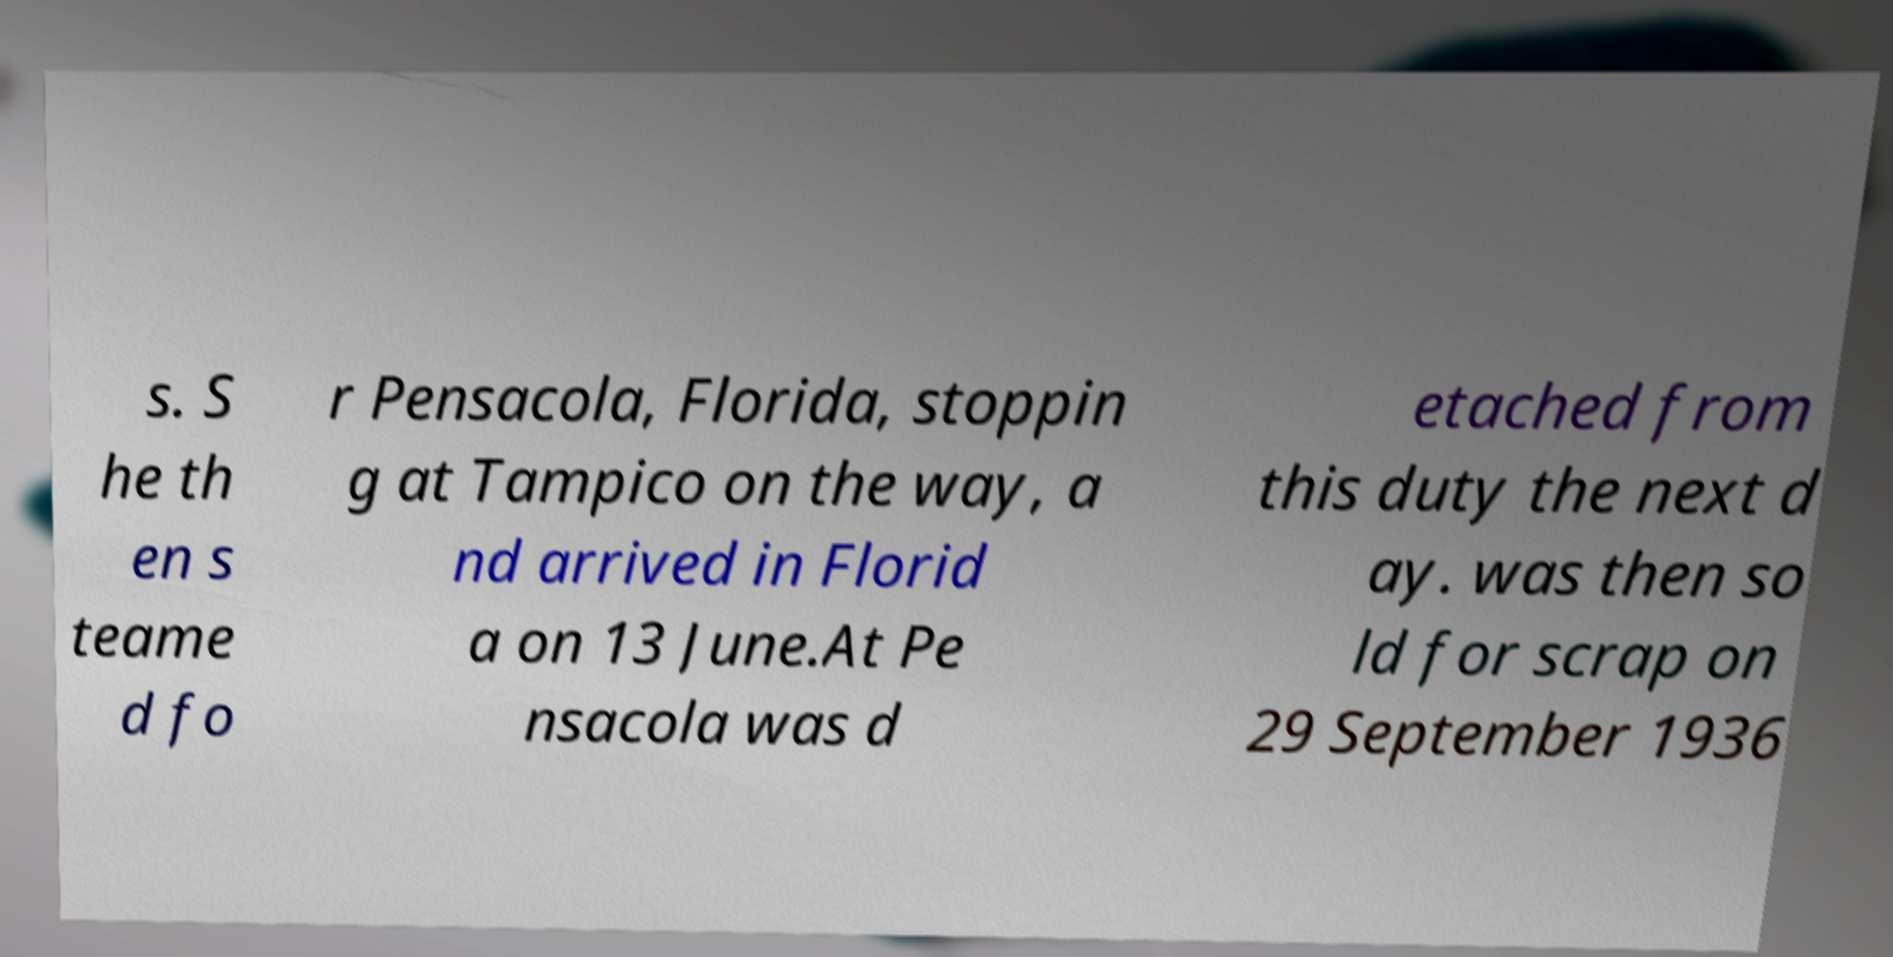Can you read and provide the text displayed in the image?This photo seems to have some interesting text. Can you extract and type it out for me? s. S he th en s teame d fo r Pensacola, Florida, stoppin g at Tampico on the way, a nd arrived in Florid a on 13 June.At Pe nsacola was d etached from this duty the next d ay. was then so ld for scrap on 29 September 1936 